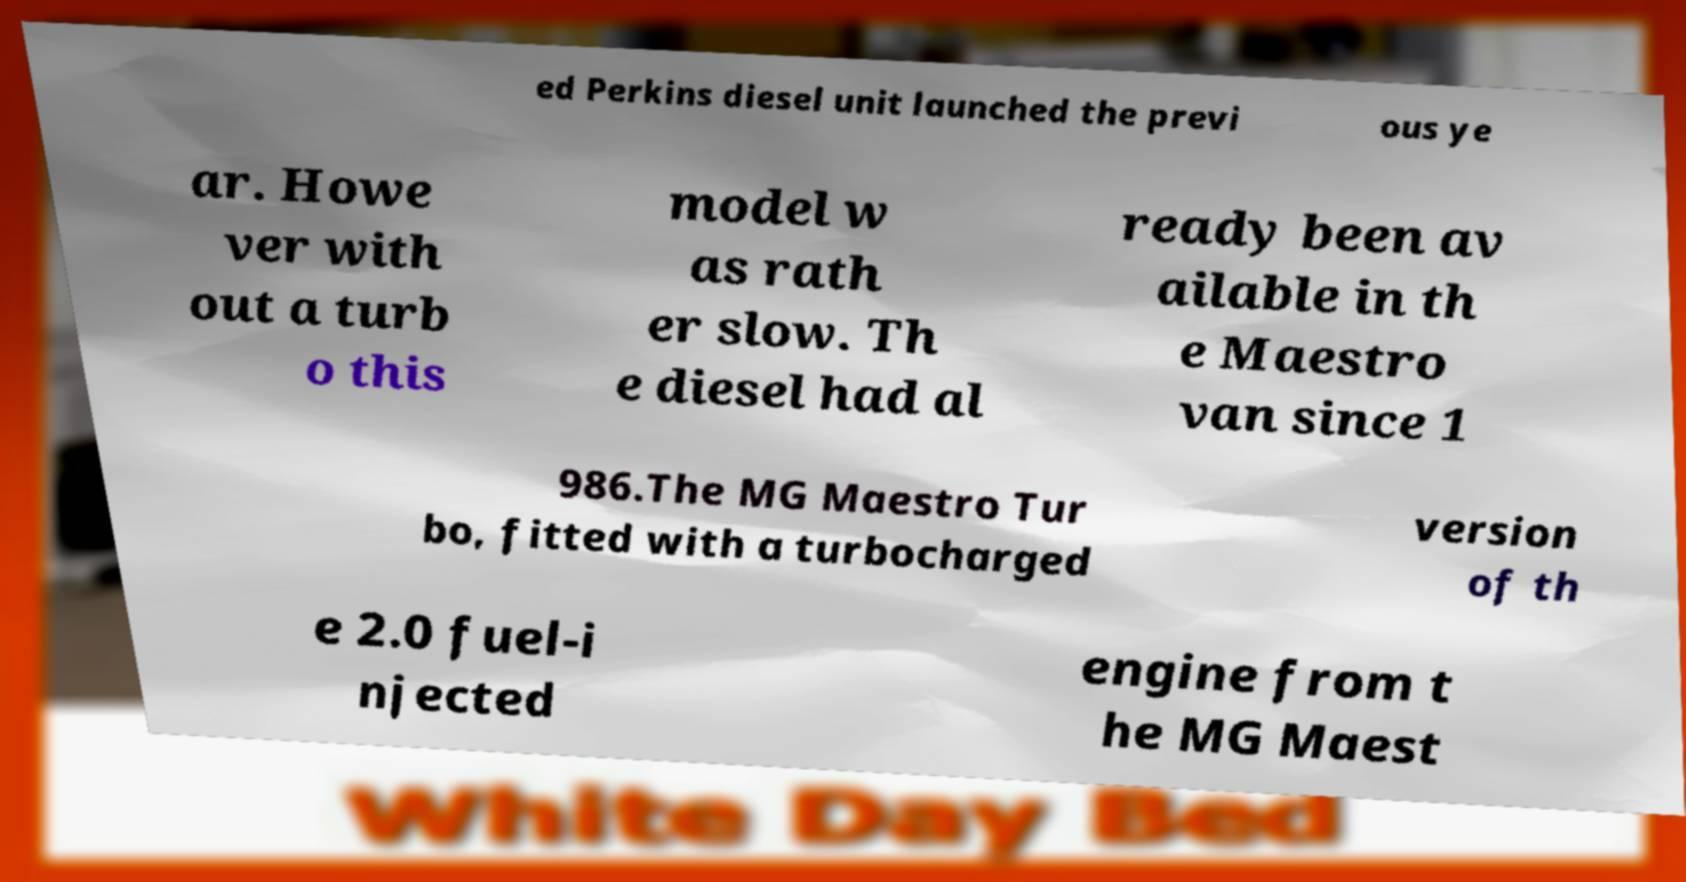Can you accurately transcribe the text from the provided image for me? ed Perkins diesel unit launched the previ ous ye ar. Howe ver with out a turb o this model w as rath er slow. Th e diesel had al ready been av ailable in th e Maestro van since 1 986.The MG Maestro Tur bo, fitted with a turbocharged version of th e 2.0 fuel-i njected engine from t he MG Maest 